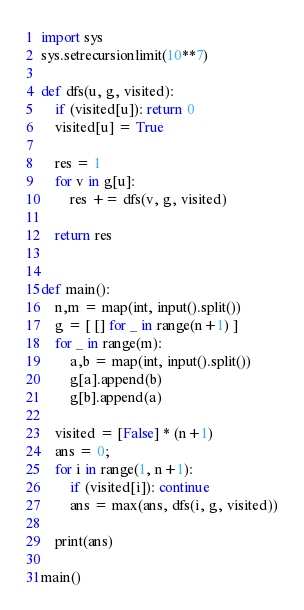<code> <loc_0><loc_0><loc_500><loc_500><_Python_>import sys
sys.setrecursionlimit(10**7)

def dfs(u, g, visited):
    if (visited[u]): return 0
    visited[u] = True

    res = 1
    for v in g[u]:
        res += dfs(v, g, visited)

    return res


def main():
    n,m = map(int, input().split())
    g = [ [] for _ in range(n+1) ]
    for _ in range(m):
        a,b = map(int, input().split())
        g[a].append(b)
        g[b].append(a)

    visited = [False] * (n+1)
    ans = 0;
    for i in range(1, n+1):
        if (visited[i]): continue
        ans = max(ans, dfs(i, g, visited))

    print(ans)

main()
</code> 